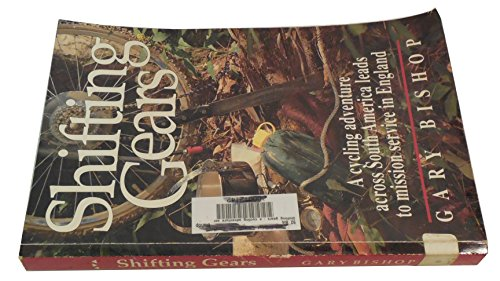What is the title of this book? The title of the book is 'Shifting Gears: A Cycling Adventure Across South America Leads to Mission Service in England', which narrates the thrilling experiences of cycling and mission work. 